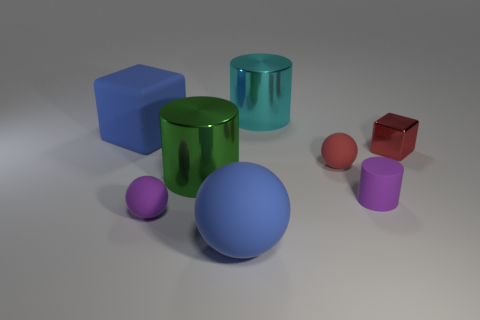There is a metallic cylinder that is in front of the large rubber object that is behind the big blue ball; what is its color?
Offer a terse response. Green. Is the number of large metallic things that are to the right of the large green cylinder less than the number of metal things to the left of the tiny shiny cube?
Ensure brevity in your answer.  Yes. What number of things are tiny balls in front of the tiny cylinder or big cylinders?
Provide a short and direct response. 3. There is a cube in front of the rubber block; is it the same size as the red rubber thing?
Your answer should be compact. Yes. Is the number of big cyan metallic cylinders in front of the purple matte sphere less than the number of tiny purple rubber cylinders?
Provide a succinct answer. Yes. There is a blue ball that is the same size as the blue rubber block; what is its material?
Make the answer very short. Rubber. How many large objects are cyan shiny objects or green rubber things?
Make the answer very short. 1. How many objects are either large blue things that are left of the blue ball or rubber objects to the right of the green cylinder?
Provide a succinct answer. 4. Are there fewer large metallic cylinders than red balls?
Give a very brief answer. No. There is a green thing that is the same size as the rubber block; what shape is it?
Your answer should be compact. Cylinder. 